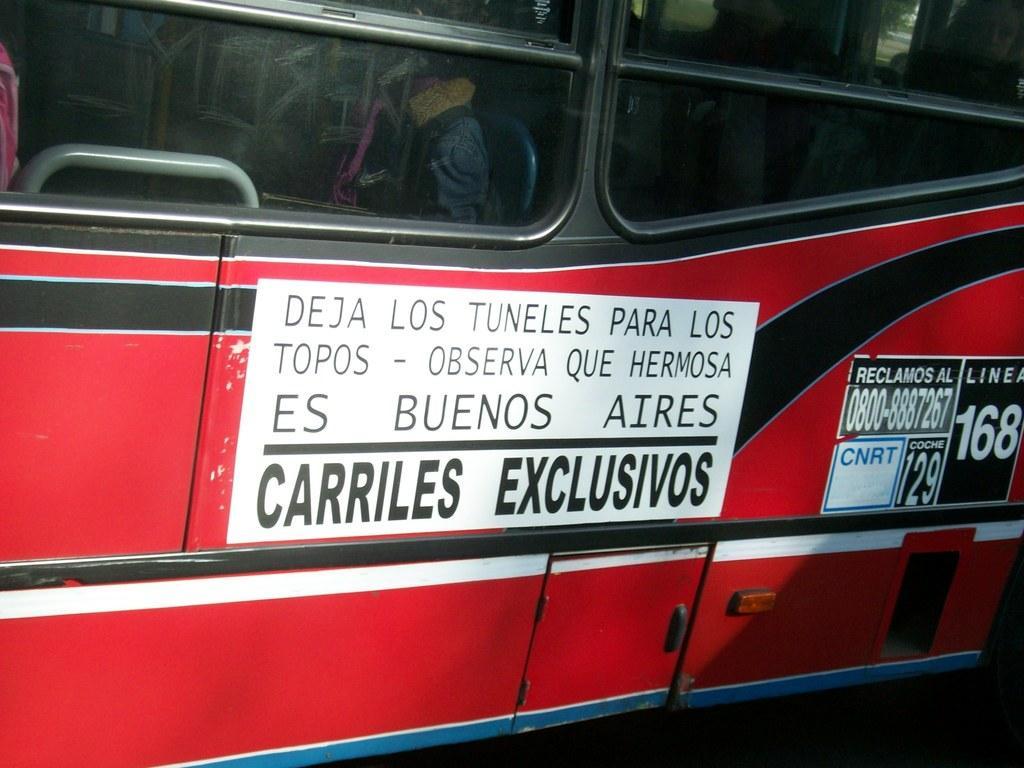How would you summarize this image in a sentence or two? In this picture we can see a vehicle with posters on it. 